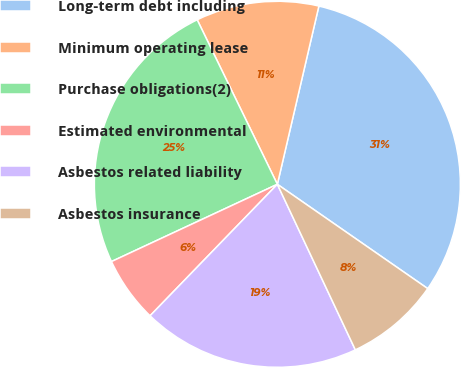Convert chart. <chart><loc_0><loc_0><loc_500><loc_500><pie_chart><fcel>Long-term debt including<fcel>Minimum operating lease<fcel>Purchase obligations(2)<fcel>Estimated environmental<fcel>Asbestos related liability<fcel>Asbestos insurance<nl><fcel>31.01%<fcel>10.86%<fcel>24.72%<fcel>5.82%<fcel>19.25%<fcel>8.34%<nl></chart> 